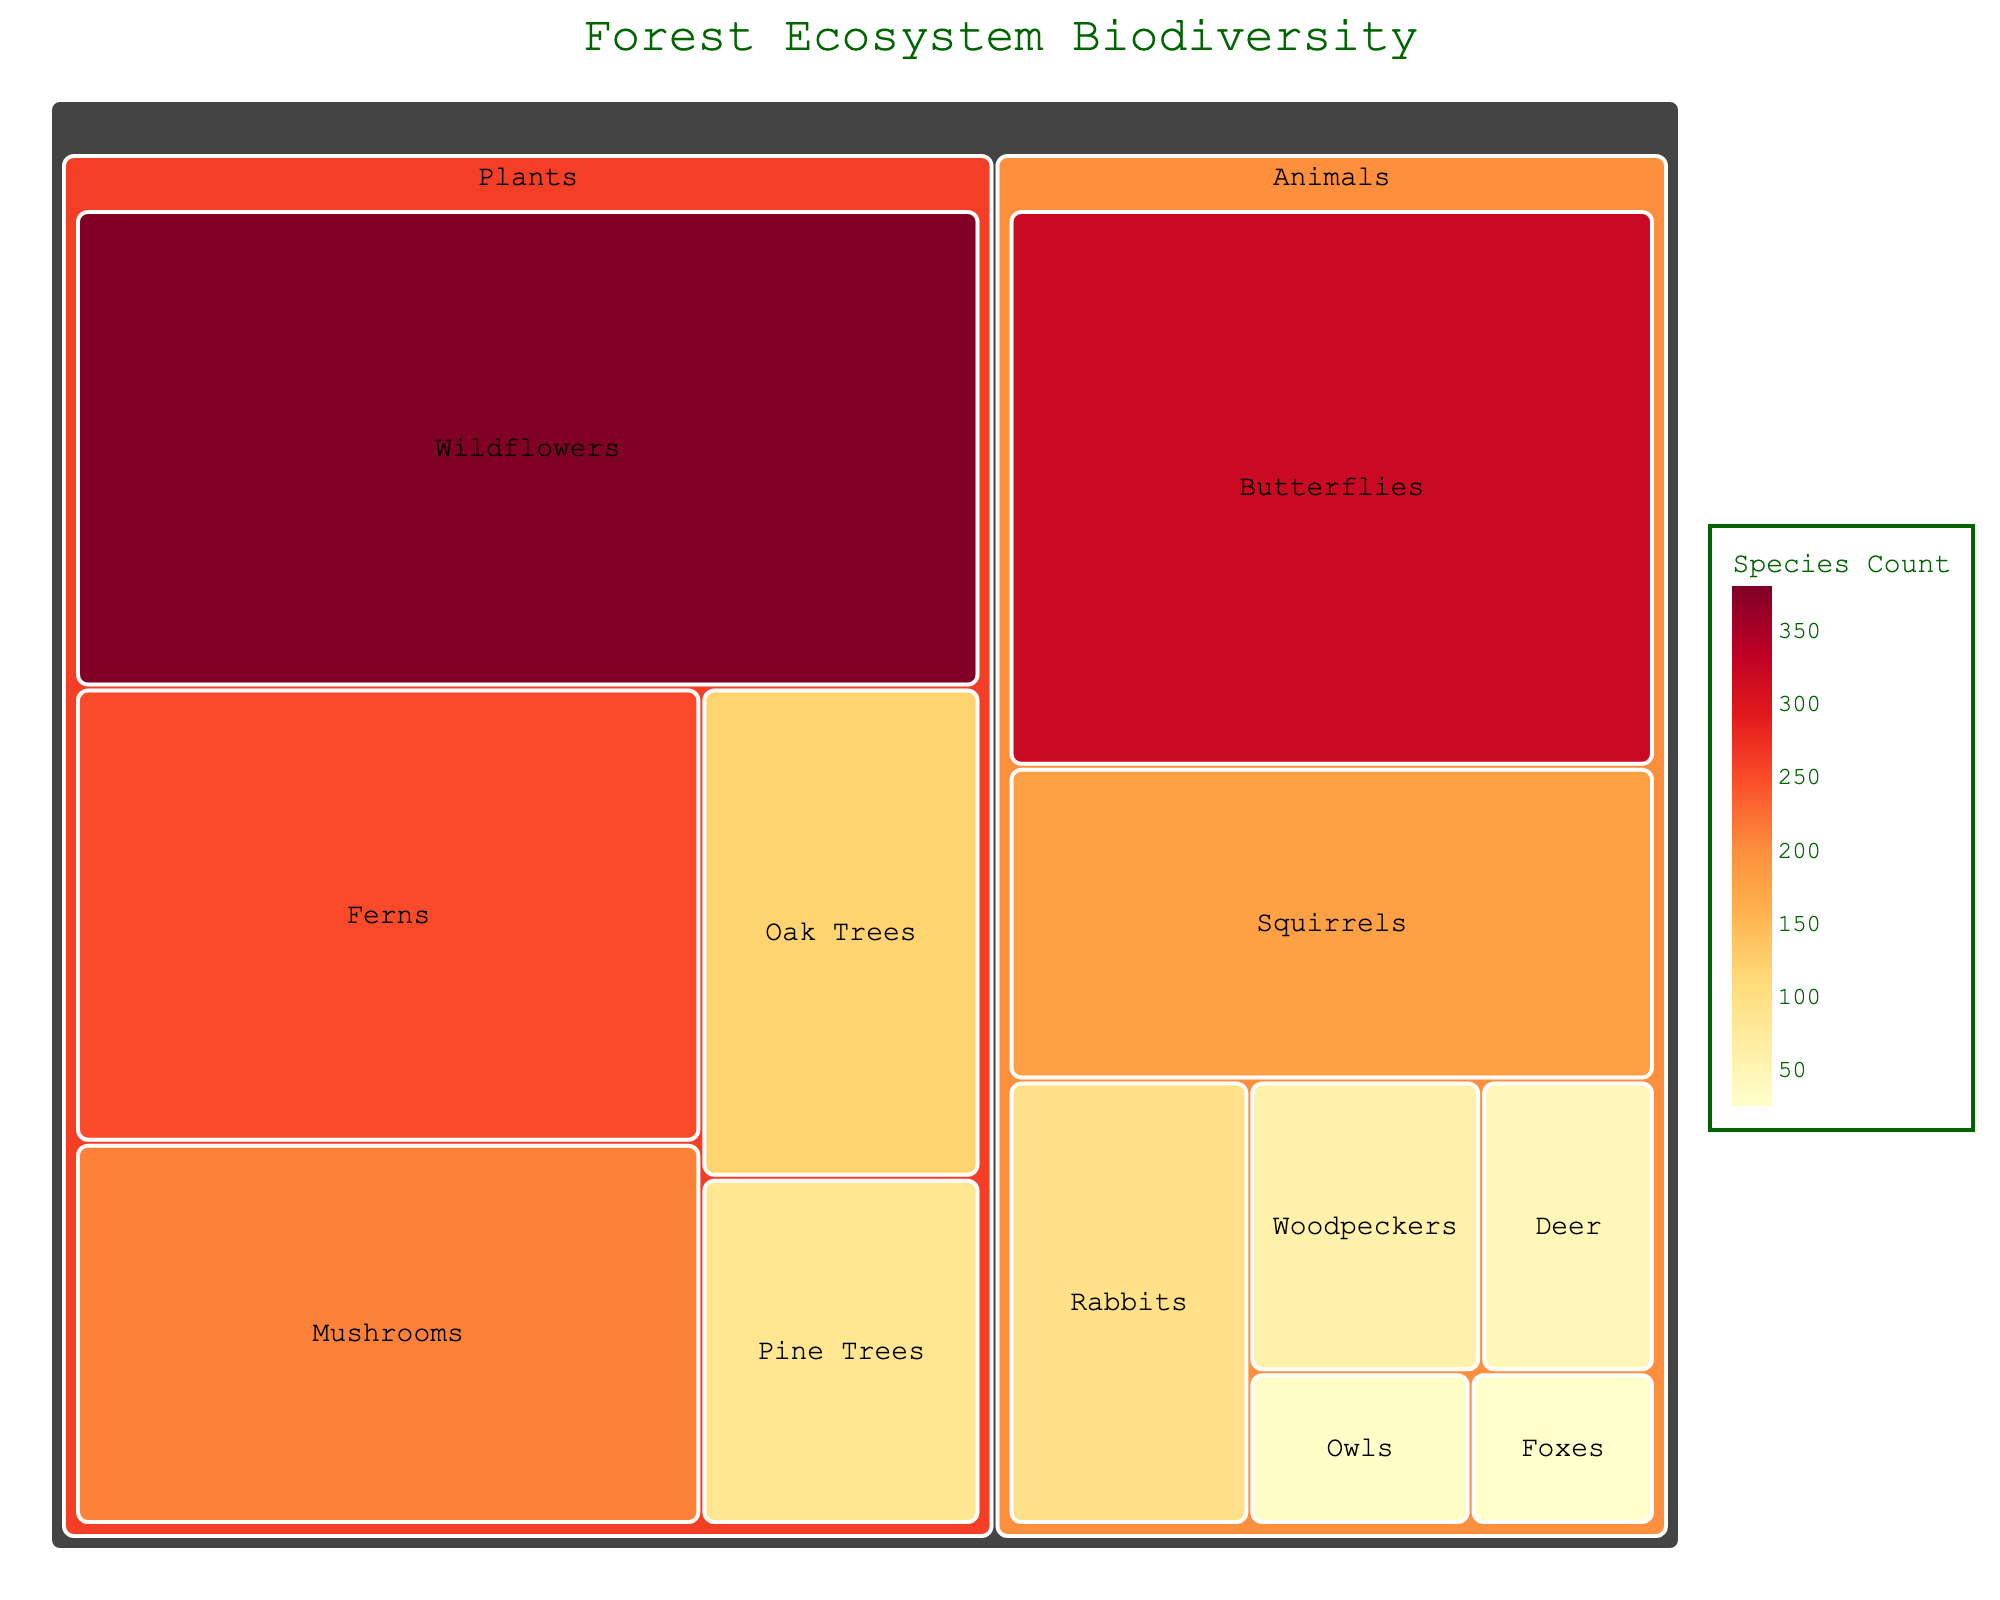What's the title of the treemap? The title is displayed at the top-center of the figure in a larger and darker green font, indicating what the visual is about.
Answer: Forest Ecosystem Biodiversity How many categories are there in the treemap? The treemap groups data into hierarchical structures, with the primary categories represented directly below the 'Forest Ecosystem' level. By visual inspection, two main categories are visible.
Answer: 2 Which species has the highest count among all plants? To determine this, look at the segments under the 'Plants' category and identify the one with the largest area, signifying the highest count.
Answer: Wildflowers What's the total count of animal species in the forest ecosystem? Sum up all the counts of different animal species provided in the data. (45 + 180 + 30 + 95 + 60 + 25 + 320) = 755
Answer: 755 Which animal has the smallest count? Compare each animal's segment size and numerical count; the one with the lowest value will be the smallest.
Answer: Foxes How does the number of Oak Trees compare to Pine Trees? Directly compare the counts given for Oak Trees (120) and Pine Trees (85) from the 'Plants' category.
Answer: Oak Trees are more than Pine Trees What's the combined count of Deer and Rabbits in the ecosystem? Sum the individual counts of Deer and Rabbits: 45 (Deer) + 95 (Rabbits) = 140
Answer: 140 Which category, Plants or Animals, has a greater total count? Calculate total counts for each category: Plants (120 + 85 + 250 + 380 + 210) = 1045, Animals (45 + 180 + 30 + 95 + 60 + 25 + 320) = 755; then compare them.
Answer: Plants What's the average count of Wildflowers and Mushrooms? Compute the average: (380 (Wildflowers) + 210 (Mushrooms)) / 2 = 295
Answer: 295 Which has a larger count, all Tree species combined or all Fern and Wildflowers combined? First sum up Tree species (Oak Trees (120) + Pine Trees (85) = 205) and then Fern and Wildflowers (250 + 380 = 630), finally compare the totals.
Answer: Fern and Wildflowers have a larger count 